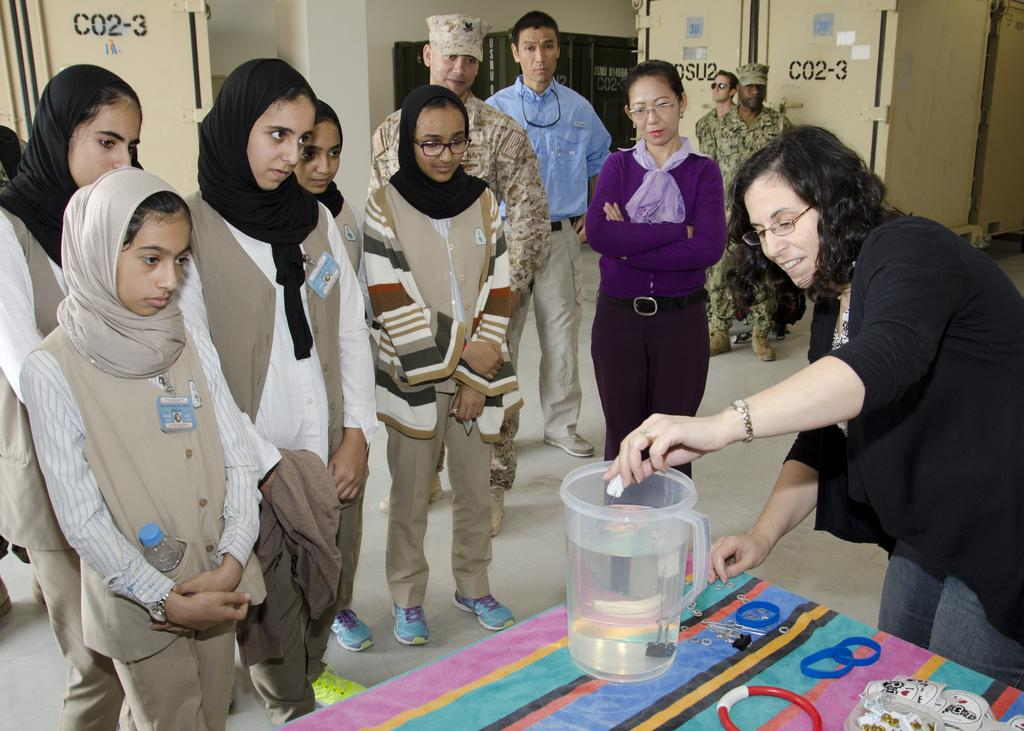<image>
Offer a succinct explanation of the picture presented. Group of people doing some testing of water and some storage cabinets with CO2-3 on them. 